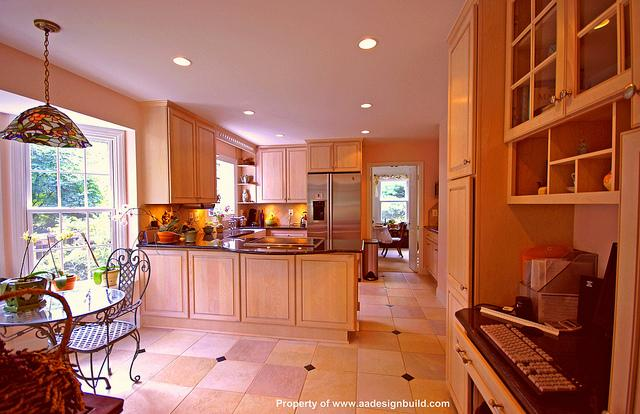What style of lamp is the one above the table?

Choices:
A) retro style
B) candle style
C) chandelier
D) tiffany style tiffany style 